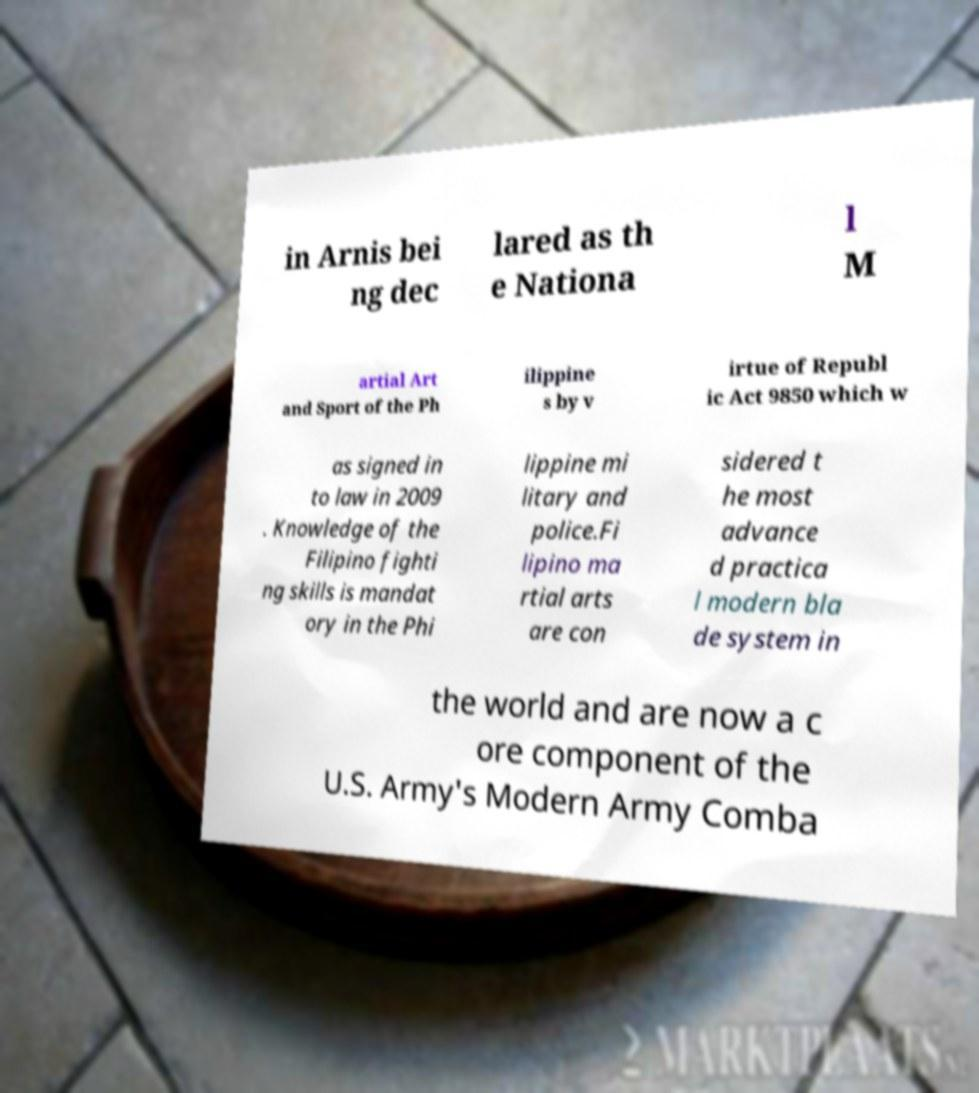Can you accurately transcribe the text from the provided image for me? in Arnis bei ng dec lared as th e Nationa l M artial Art and Sport of the Ph ilippine s by v irtue of Republ ic Act 9850 which w as signed in to law in 2009 . Knowledge of the Filipino fighti ng skills is mandat ory in the Phi lippine mi litary and police.Fi lipino ma rtial arts are con sidered t he most advance d practica l modern bla de system in the world and are now a c ore component of the U.S. Army's Modern Army Comba 